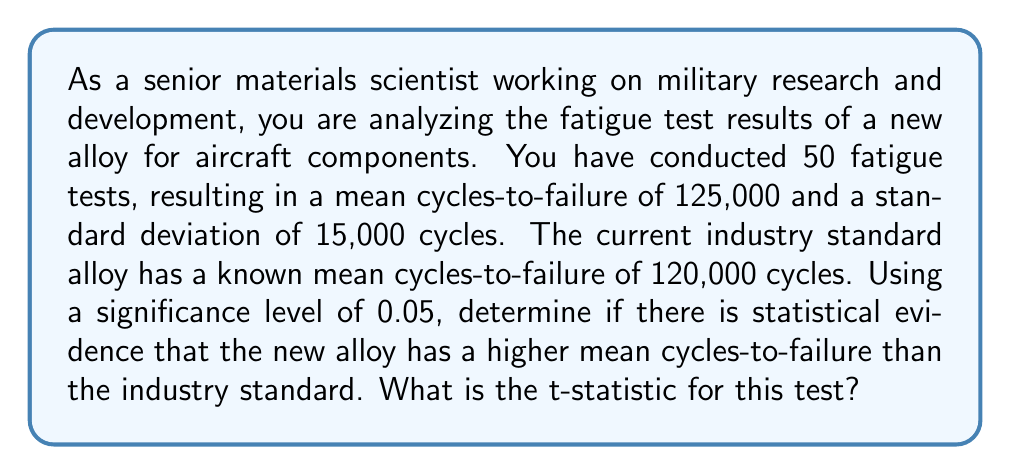Give your solution to this math problem. To analyze the statistical significance of the material fatigue test results, we'll use a one-tailed t-test. This is appropriate because we want to determine if the new alloy has a higher mean cycles-to-failure than the industry standard.

Given:
- Sample size: $n = 50$
- Sample mean: $\bar{x} = 125,000$ cycles
- Sample standard deviation: $s = 15,000$ cycles
- Industry standard (null hypothesis) mean: $\mu_0 = 120,000$ cycles
- Significance level: $\alpha = 0.05$

Step 1: State the null and alternative hypotheses.
$H_0: \mu \leq 120,000$ (new alloy is not better than the industry standard)
$H_a: \mu > 120,000$ (new alloy is better than the industry standard)

Step 2: Calculate the standard error of the mean.
$SE = \frac{s}{\sqrt{n}} = \frac{15,000}{\sqrt{50}} = 2,121.32$

Step 3: Calculate the t-statistic.
The t-statistic is given by the formula:

$$t = \frac{\bar{x} - \mu_0}{SE}$$

Substituting the values:

$$t = \frac{125,000 - 120,000}{2,121.32} = \frac{5,000}{2,121.32} = 2.357$$

Step 4: Interpret the result.
The calculated t-statistic is 2.357. To determine if this is statistically significant, we would compare it to the critical t-value for a one-tailed test with 49 degrees of freedom (n-1) and α = 0.05. However, the question only asks for the t-statistic calculation.
Answer: The t-statistic for this test is 2.357. 